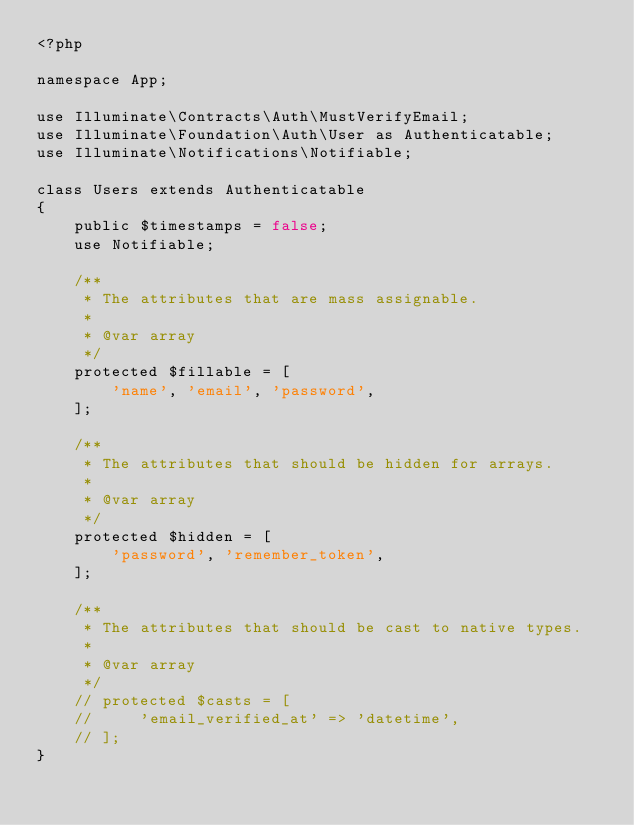Convert code to text. <code><loc_0><loc_0><loc_500><loc_500><_PHP_><?php

namespace App;

use Illuminate\Contracts\Auth\MustVerifyEmail;
use Illuminate\Foundation\Auth\User as Authenticatable;
use Illuminate\Notifications\Notifiable;

class Users extends Authenticatable
{
    public $timestamps = false;
    use Notifiable;

    /**
     * The attributes that are mass assignable.
     *
     * @var array
     */
    protected $fillable = [
        'name', 'email', 'password',
    ];

    /**
     * The attributes that should be hidden for arrays.
     *
     * @var array
     */
    protected $hidden = [
        'password', 'remember_token',
    ];

    /**
     * The attributes that should be cast to native types.
     *
     * @var array
     */
    // protected $casts = [
    //     'email_verified_at' => 'datetime',
    // ];
}</code> 